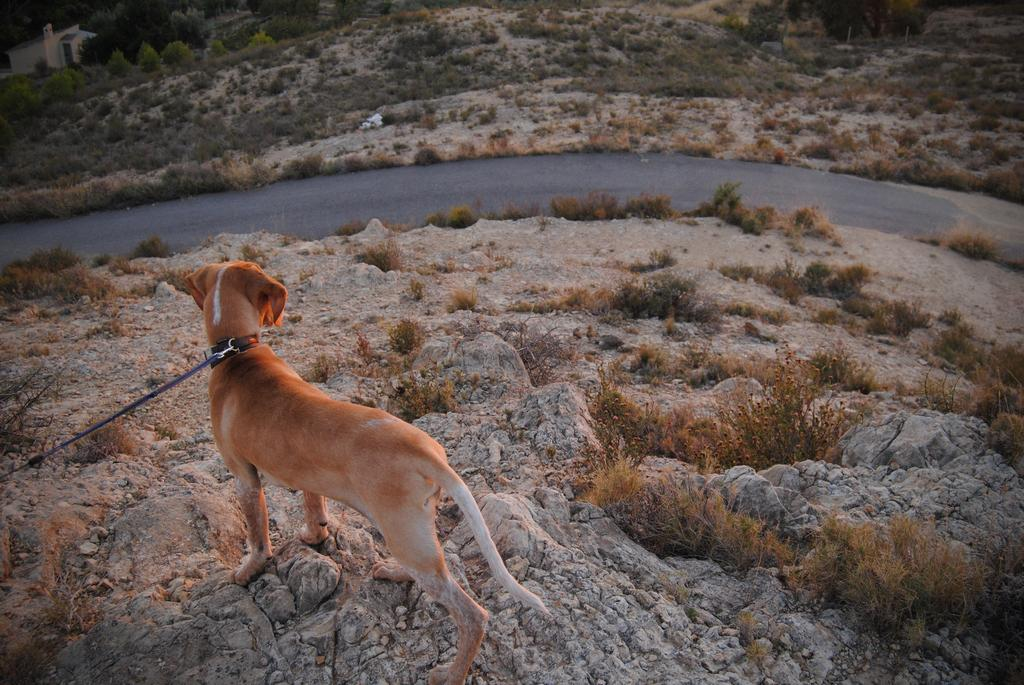What type of animal is in the image? There is a brown and white dog in the image. What is the dog doing in the image? The dog is standing. What type of terrain is visible in the image? There is grass in the image. What type of man-made structure is visible in the image? There is a road and a building in the image. What type of natural elements are visible in the background of the image? There are trees in the background of the image. What type of zephyr is blowing in the image? There is no mention of a zephyr in the image, as it refers to a gentle breeze, which is not visible in the image. 